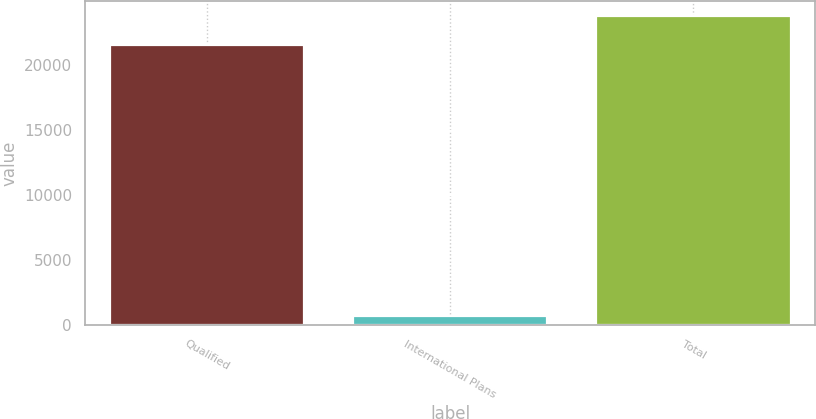Convert chart to OTSL. <chart><loc_0><loc_0><loc_500><loc_500><bar_chart><fcel>Qualified<fcel>International Plans<fcel>Total<nl><fcel>21532<fcel>746<fcel>23717.4<nl></chart> 